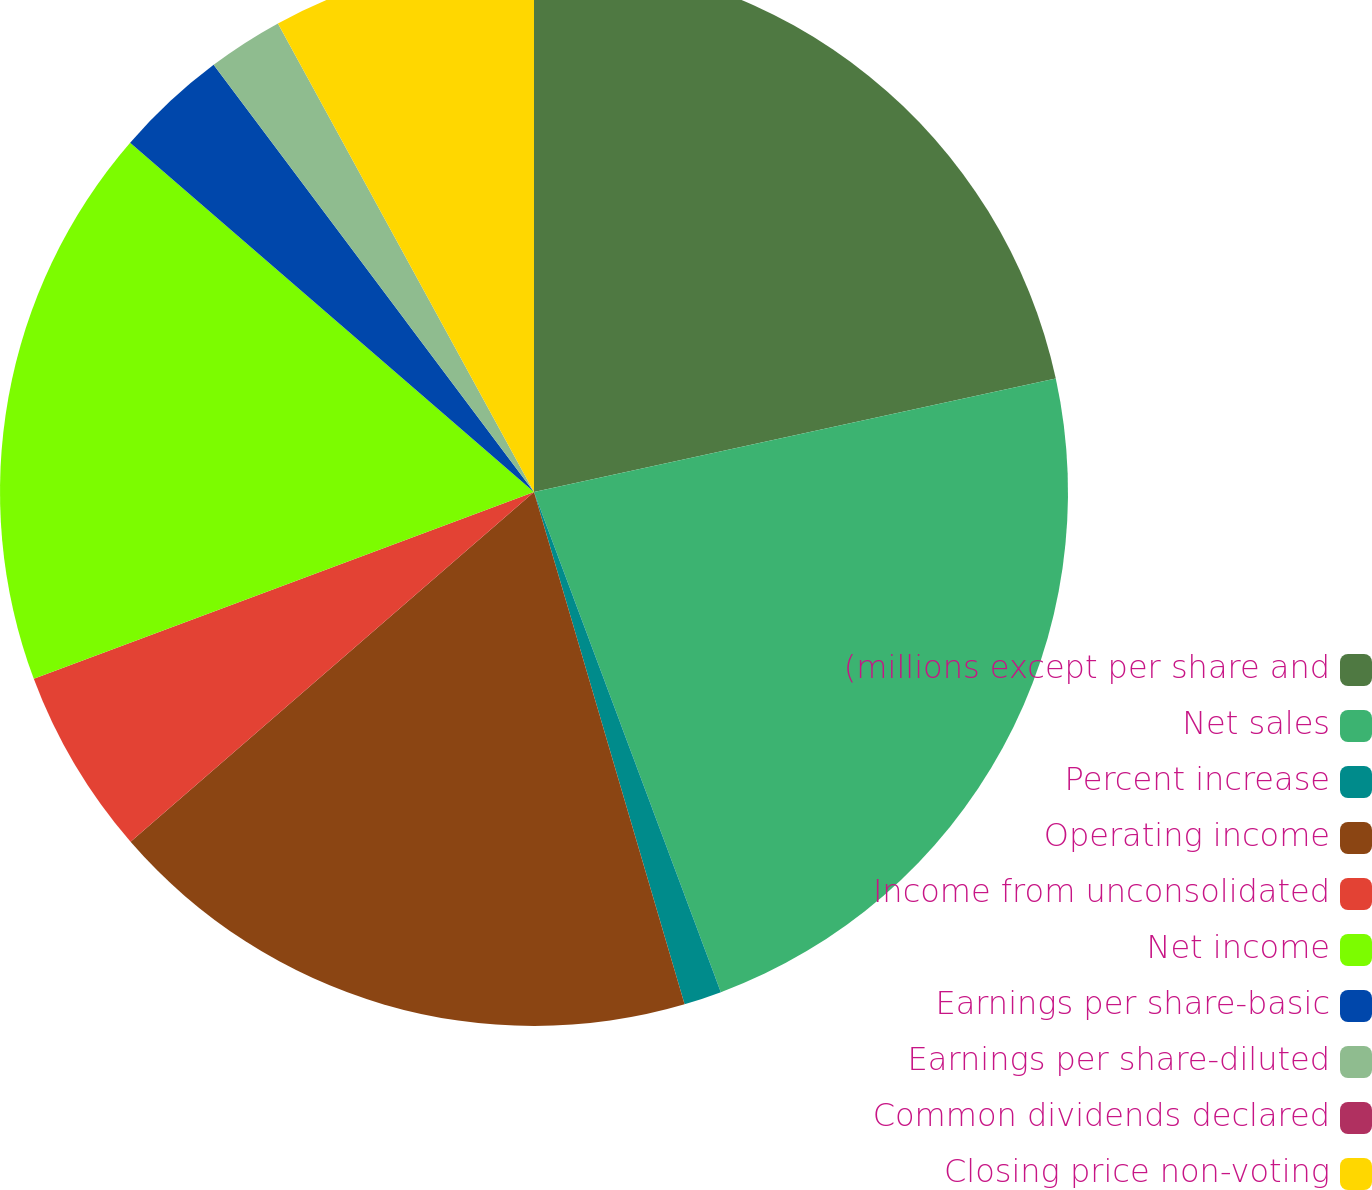Convert chart to OTSL. <chart><loc_0><loc_0><loc_500><loc_500><pie_chart><fcel>(millions except per share and<fcel>Net sales<fcel>Percent increase<fcel>Operating income<fcel>Income from unconsolidated<fcel>Net income<fcel>Earnings per share-basic<fcel>Earnings per share-diluted<fcel>Common dividends declared<fcel>Closing price non-voting<nl><fcel>21.59%<fcel>22.72%<fcel>1.14%<fcel>18.18%<fcel>5.68%<fcel>17.04%<fcel>3.41%<fcel>2.28%<fcel>0.0%<fcel>7.96%<nl></chart> 